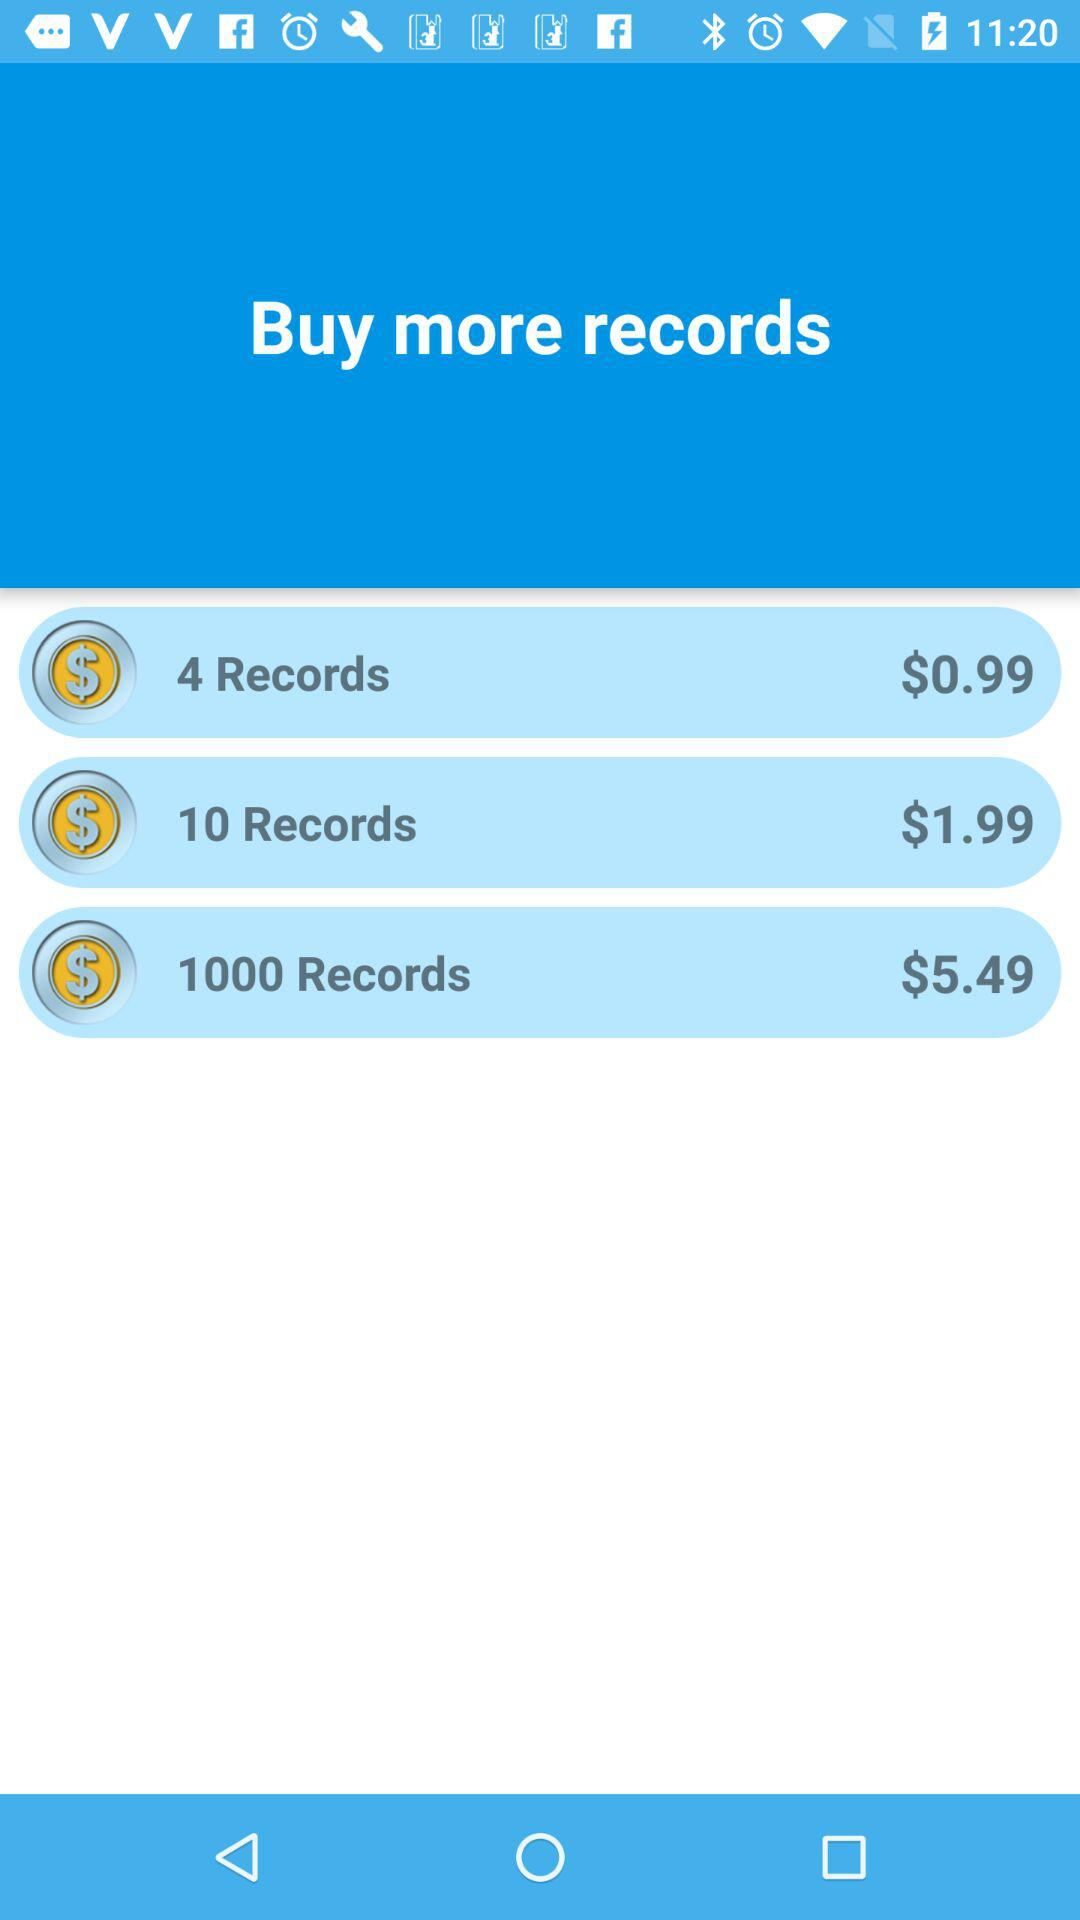How many more records do you get for the 1000 records option than the 10 records option?
Answer the question using a single word or phrase. 990 